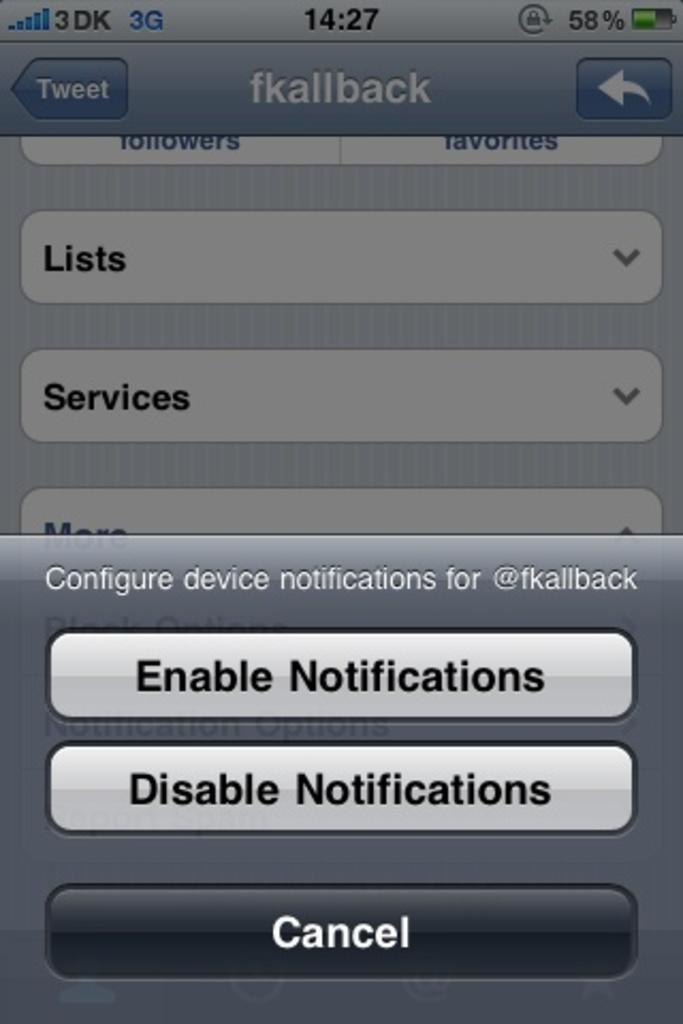<image>
Describe the image concisely. The screen of an iphone that allows for notification settings to be changed is displayed. 